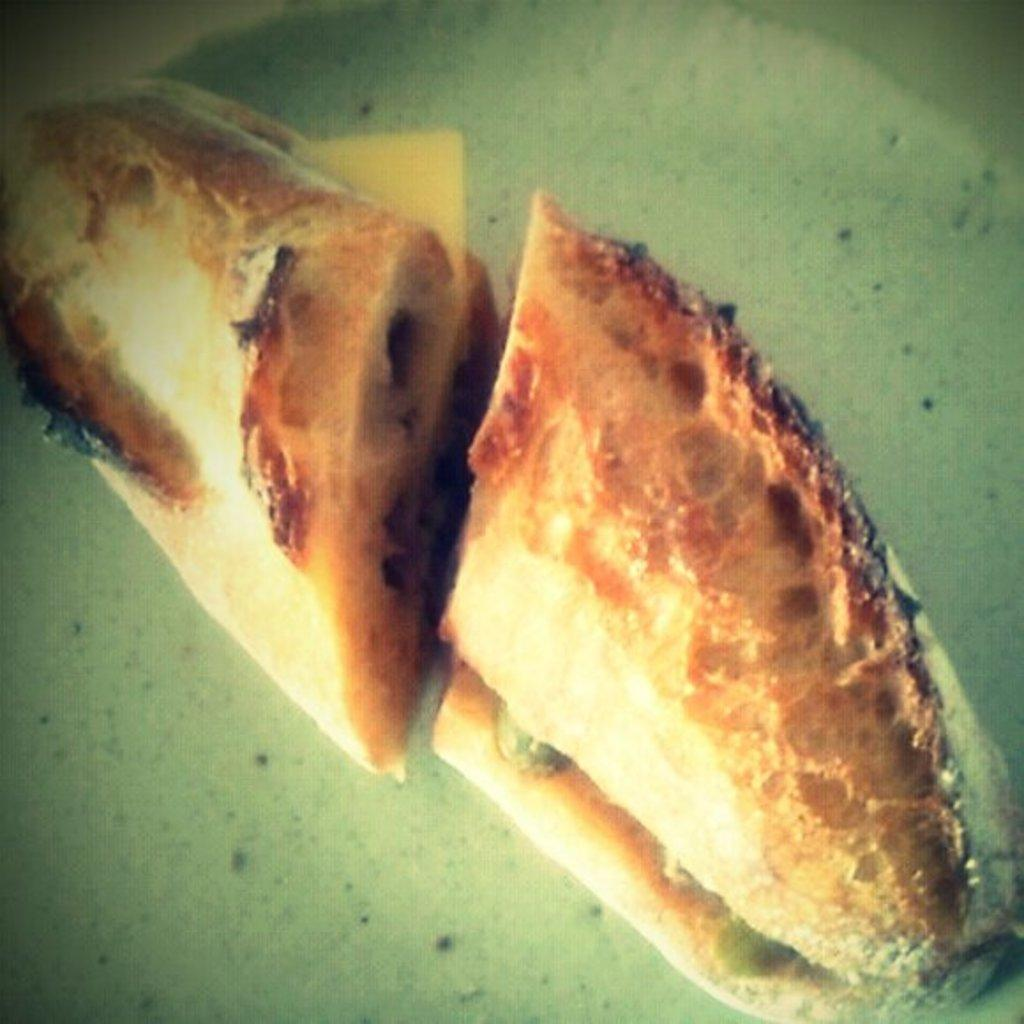What is the main subject of the image? There is a food item in the center of the image. What type of chain can be seen hanging from the food item in the image? There is no chain present in the image; it only features a food item. What color is the chalk used to draw on the food item in the image? There is no chalk or drawing on the food item in the image. 